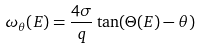<formula> <loc_0><loc_0><loc_500><loc_500>\omega _ { \theta } ( E ) = \frac { 4 \sigma } { q } \tan ( \Theta ( E ) - \theta )</formula> 